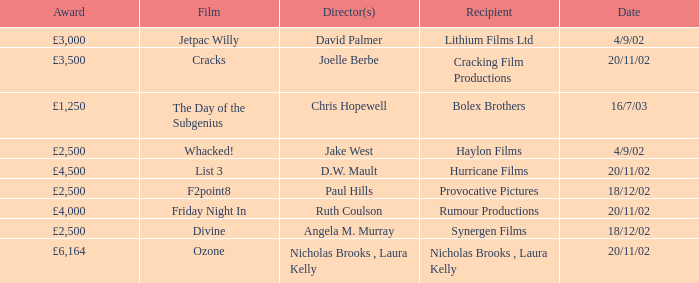What award did the film Ozone win? £6,164. 